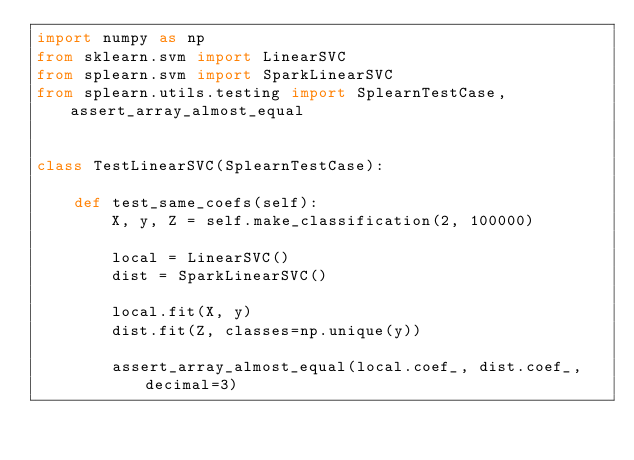<code> <loc_0><loc_0><loc_500><loc_500><_Python_>import numpy as np
from sklearn.svm import LinearSVC
from splearn.svm import SparkLinearSVC
from splearn.utils.testing import SplearnTestCase, assert_array_almost_equal


class TestLinearSVC(SplearnTestCase):

    def test_same_coefs(self):
        X, y, Z = self.make_classification(2, 100000)

        local = LinearSVC()
        dist = SparkLinearSVC()

        local.fit(X, y)
        dist.fit(Z, classes=np.unique(y))

        assert_array_almost_equal(local.coef_, dist.coef_, decimal=3)
</code> 